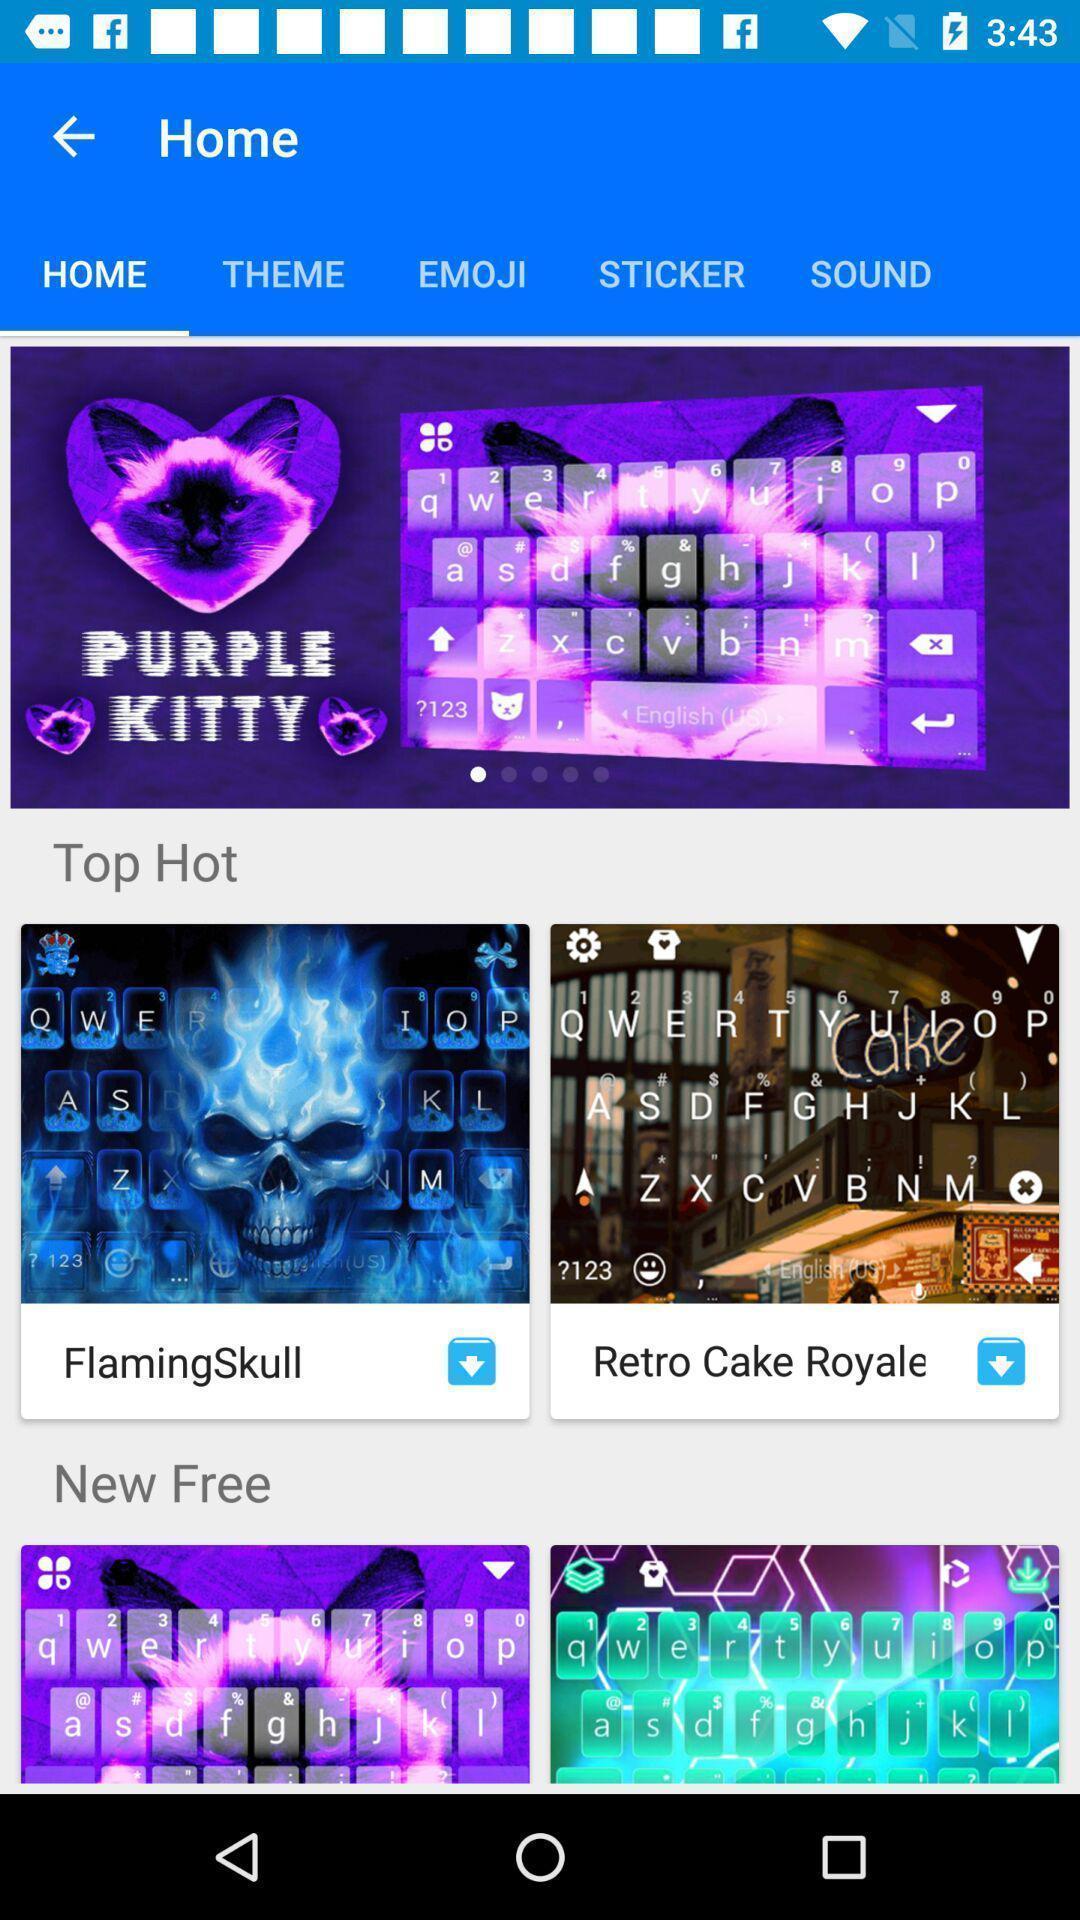Provide a description of this screenshot. Screen displaying the various themes in home tab. 